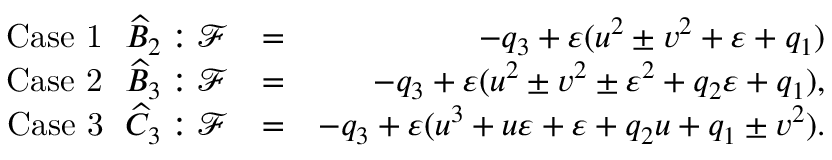<formula> <loc_0><loc_0><loc_500><loc_500>\begin{array} { r l r } { C a s e \ 1 \quad w i d e h a t B _ { 2 } \colon \mathcal { F } } & { = } & { - q _ { 3 } + \varepsilon ( u ^ { 2 } \pm v ^ { 2 } + \varepsilon + q _ { 1 } ) } \\ { C a s e \ 2 \quad w i d e h a t B _ { 3 } \colon \mathcal { F } } & { = } & { - q _ { 3 } + \varepsilon ( u ^ { 2 } \pm v ^ { 2 } \pm \varepsilon ^ { 2 } + q _ { 2 } \varepsilon + q _ { 1 } ) , } \\ { C a s e \ 3 \quad w i d e h a t C _ { 3 } \colon \mathcal { F } } & { = } & { - q _ { 3 } + \varepsilon ( u ^ { 3 } + u \varepsilon + \varepsilon + q _ { 2 } u + q _ { 1 } \pm v ^ { 2 } ) . } \end{array}</formula> 